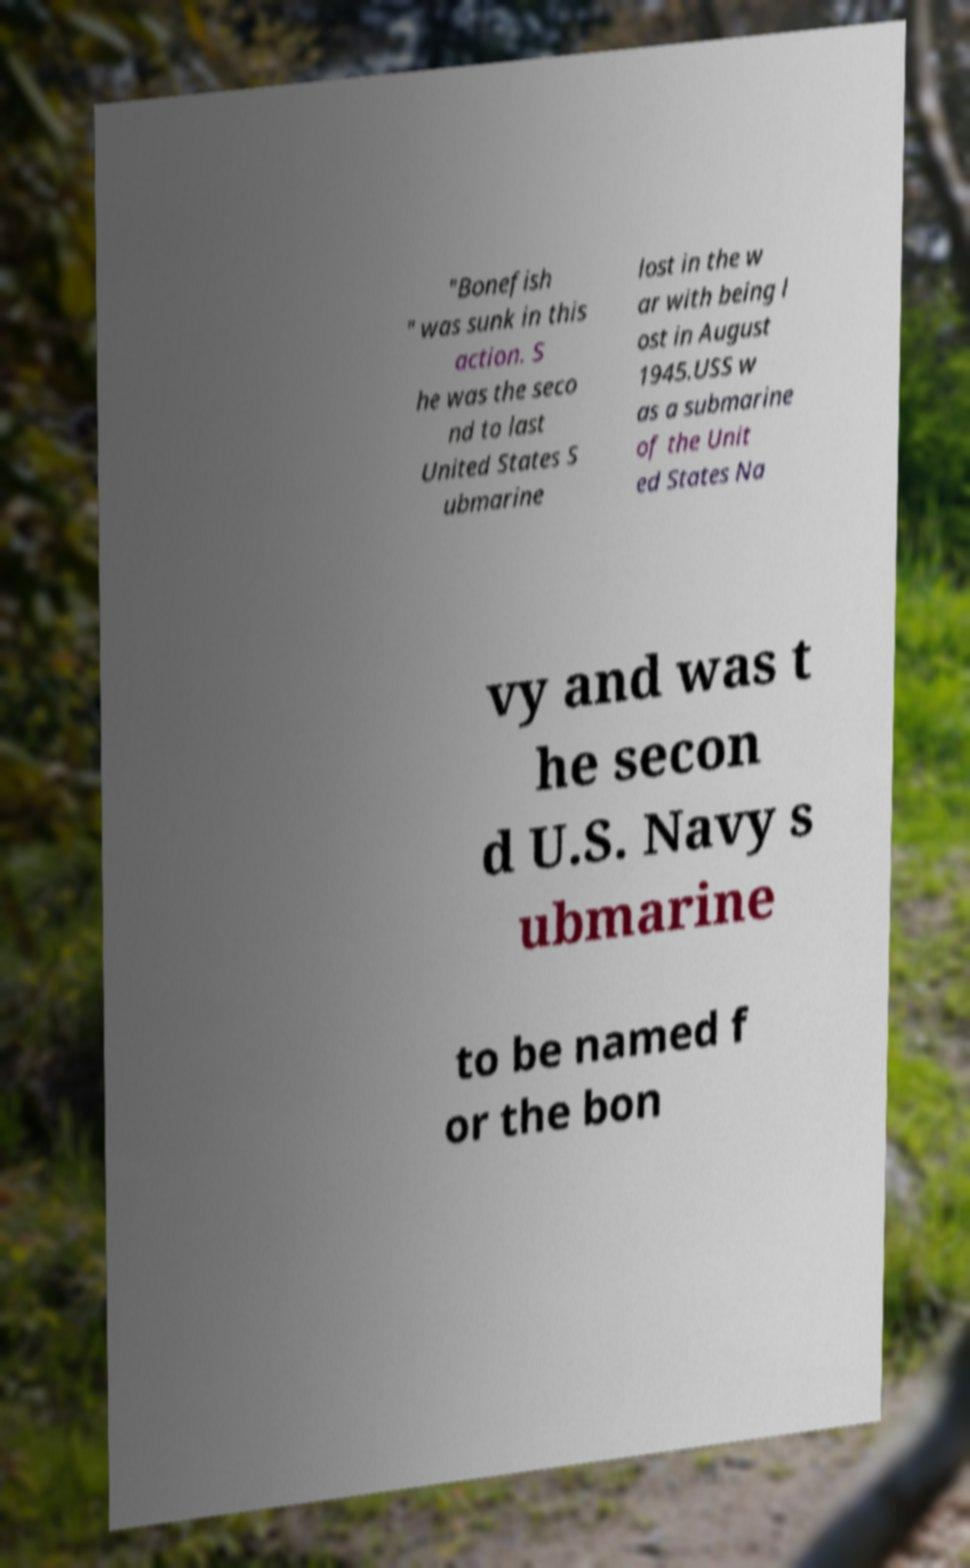What messages or text are displayed in this image? I need them in a readable, typed format. "Bonefish " was sunk in this action. S he was the seco nd to last United States S ubmarine lost in the w ar with being l ost in August 1945.USS w as a submarine of the Unit ed States Na vy and was t he secon d U.S. Navy s ubmarine to be named f or the bon 